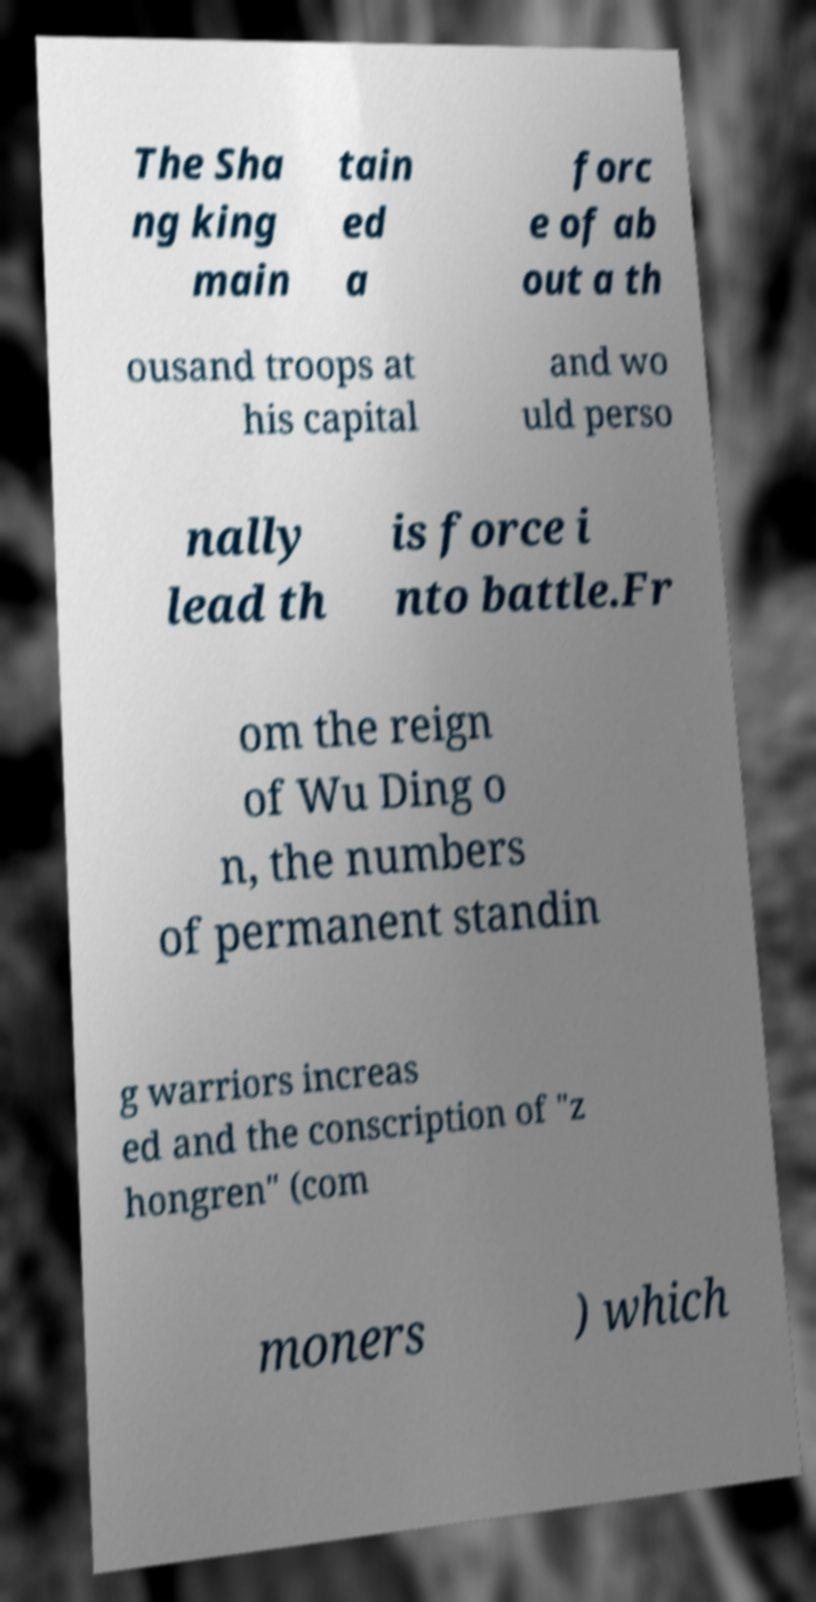Please identify and transcribe the text found in this image. The Sha ng king main tain ed a forc e of ab out a th ousand troops at his capital and wo uld perso nally lead th is force i nto battle.Fr om the reign of Wu Ding o n, the numbers of permanent standin g warriors increas ed and the conscription of "z hongren" (com moners ) which 